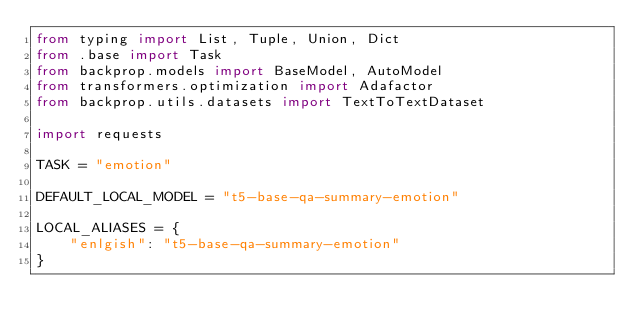<code> <loc_0><loc_0><loc_500><loc_500><_Python_>from typing import List, Tuple, Union, Dict
from .base import Task
from backprop.models import BaseModel, AutoModel
from transformers.optimization import Adafactor
from backprop.utils.datasets import TextToTextDataset

import requests

TASK = "emotion"

DEFAULT_LOCAL_MODEL = "t5-base-qa-summary-emotion"

LOCAL_ALIASES = {
    "enlgish": "t5-base-qa-summary-emotion"
}
</code> 